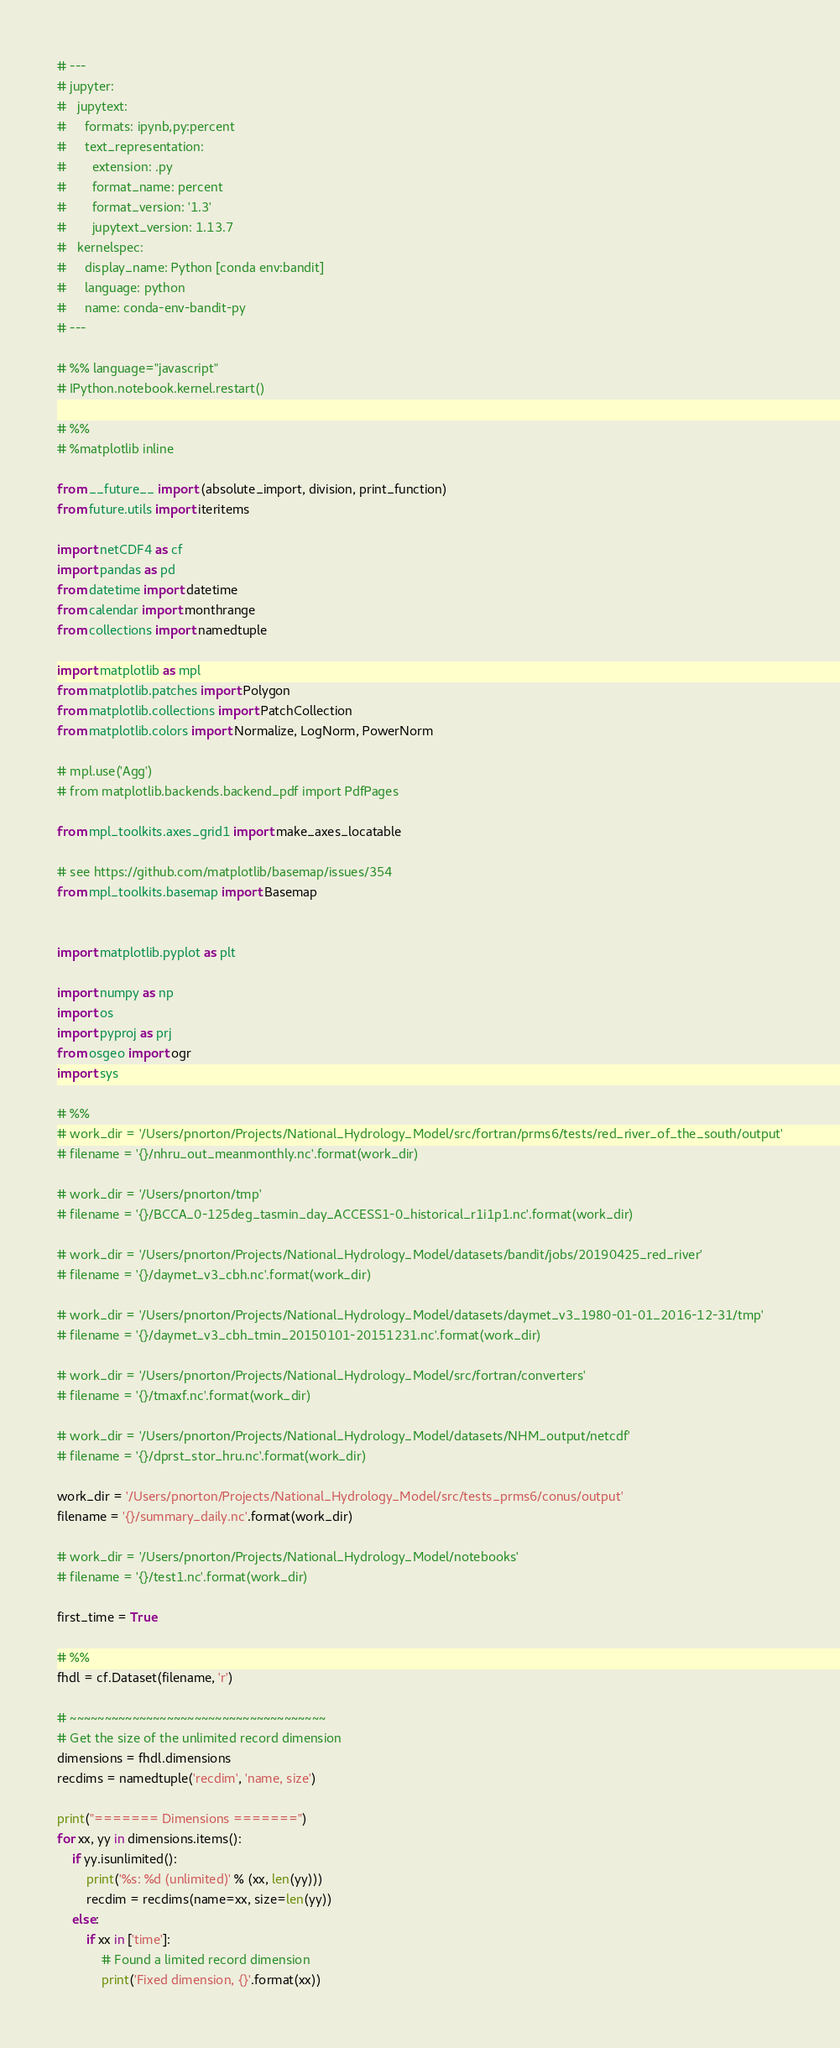Convert code to text. <code><loc_0><loc_0><loc_500><loc_500><_Python_># ---
# jupyter:
#   jupytext:
#     formats: ipynb,py:percent
#     text_representation:
#       extension: .py
#       format_name: percent
#       format_version: '1.3'
#       jupytext_version: 1.13.7
#   kernelspec:
#     display_name: Python [conda env:bandit]
#     language: python
#     name: conda-env-bandit-py
# ---

# %% language="javascript"
# IPython.notebook.kernel.restart()

# %%
# %matplotlib inline

from __future__ import (absolute_import, division, print_function)
from future.utils import iteritems

import netCDF4 as cf
import pandas as pd
from datetime import datetime
from calendar import monthrange
from collections import namedtuple

import matplotlib as mpl
from matplotlib.patches import Polygon
from matplotlib.collections import PatchCollection
from matplotlib.colors import Normalize, LogNorm, PowerNorm

# mpl.use('Agg')
# from matplotlib.backends.backend_pdf import PdfPages

from mpl_toolkits.axes_grid1 import make_axes_locatable

# see https://github.com/matplotlib/basemap/issues/354
from mpl_toolkits.basemap import Basemap


import matplotlib.pyplot as plt

import numpy as np
import os
import pyproj as prj
from osgeo import ogr
import sys

# %%
# work_dir = '/Users/pnorton/Projects/National_Hydrology_Model/src/fortran/prms6/tests/red_river_of_the_south/output'
# filename = '{}/nhru_out_meanmonthly.nc'.format(work_dir)

# work_dir = '/Users/pnorton/tmp'
# filename = '{}/BCCA_0-125deg_tasmin_day_ACCESS1-0_historical_r1i1p1.nc'.format(work_dir)

# work_dir = '/Users/pnorton/Projects/National_Hydrology_Model/datasets/bandit/jobs/20190425_red_river'
# filename = '{}/daymet_v3_cbh.nc'.format(work_dir)

# work_dir = '/Users/pnorton/Projects/National_Hydrology_Model/datasets/daymet_v3_1980-01-01_2016-12-31/tmp'
# filename = '{}/daymet_v3_cbh_tmin_20150101-20151231.nc'.format(work_dir)

# work_dir = '/Users/pnorton/Projects/National_Hydrology_Model/src/fortran/converters'
# filename = '{}/tmaxf.nc'.format(work_dir)

# work_dir = '/Users/pnorton/Projects/National_Hydrology_Model/datasets/NHM_output/netcdf'
# filename = '{}/dprst_stor_hru.nc'.format(work_dir)

work_dir = '/Users/pnorton/Projects/National_Hydrology_Model/src/tests_prms6/conus/output'
filename = '{}/summary_daily.nc'.format(work_dir)

# work_dir = '/Users/pnorton/Projects/National_Hydrology_Model/notebooks'
# filename = '{}/test1.nc'.format(work_dir)

first_time = True

# %%
fhdl = cf.Dataset(filename, 'r')

# ~~~~~~~~~~~~~~~~~~~~~~~~~~~~~~~~~~~~~
# Get the size of the unlimited record dimension
dimensions = fhdl.dimensions
recdims = namedtuple('recdim', 'name, size')

print("======= Dimensions =======")
for xx, yy in dimensions.items():
    if yy.isunlimited():
        print('%s: %d (unlimited)' % (xx, len(yy)))
        recdim = recdims(name=xx, size=len(yy))
    else:
        if xx in ['time']:
            # Found a limited record dimension
            print('Fixed dimension, {}'.format(xx))</code> 